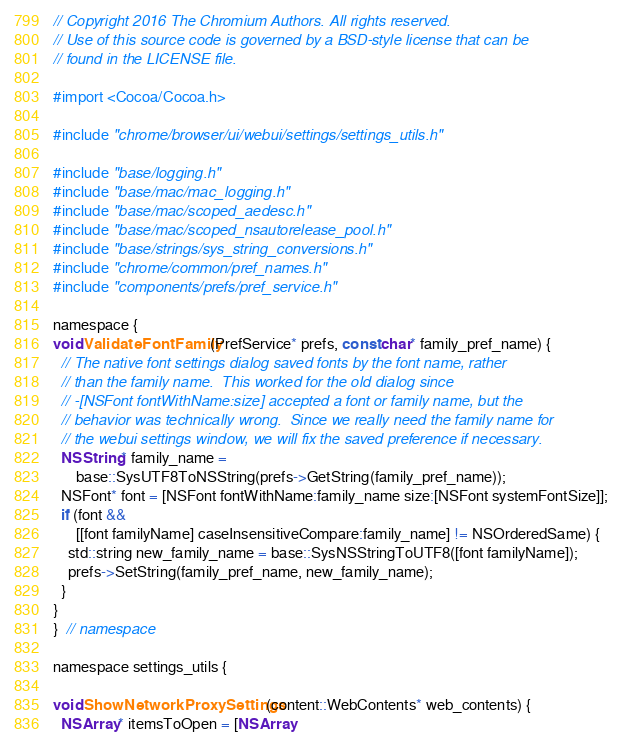Convert code to text. <code><loc_0><loc_0><loc_500><loc_500><_ObjectiveC_>// Copyright 2016 The Chromium Authors. All rights reserved.
// Use of this source code is governed by a BSD-style license that can be
// found in the LICENSE file.

#import <Cocoa/Cocoa.h>

#include "chrome/browser/ui/webui/settings/settings_utils.h"

#include "base/logging.h"
#include "base/mac/mac_logging.h"
#include "base/mac/scoped_aedesc.h"
#include "base/mac/scoped_nsautorelease_pool.h"
#include "base/strings/sys_string_conversions.h"
#include "chrome/common/pref_names.h"
#include "components/prefs/pref_service.h"

namespace {
void ValidateFontFamily(PrefService* prefs, const char* family_pref_name) {
  // The native font settings dialog saved fonts by the font name, rather
  // than the family name.  This worked for the old dialog since
  // -[NSFont fontWithName:size] accepted a font or family name, but the
  // behavior was technically wrong.  Since we really need the family name for
  // the webui settings window, we will fix the saved preference if necessary.
  NSString* family_name =
      base::SysUTF8ToNSString(prefs->GetString(family_pref_name));
  NSFont* font = [NSFont fontWithName:family_name size:[NSFont systemFontSize]];
  if (font &&
      [[font familyName] caseInsensitiveCompare:family_name] != NSOrderedSame) {
    std::string new_family_name = base::SysNSStringToUTF8([font familyName]);
    prefs->SetString(family_pref_name, new_family_name);
  }
}
}  // namespace

namespace settings_utils {

void ShowNetworkProxySettings(content::WebContents* web_contents) {
  NSArray* itemsToOpen = [NSArray</code> 